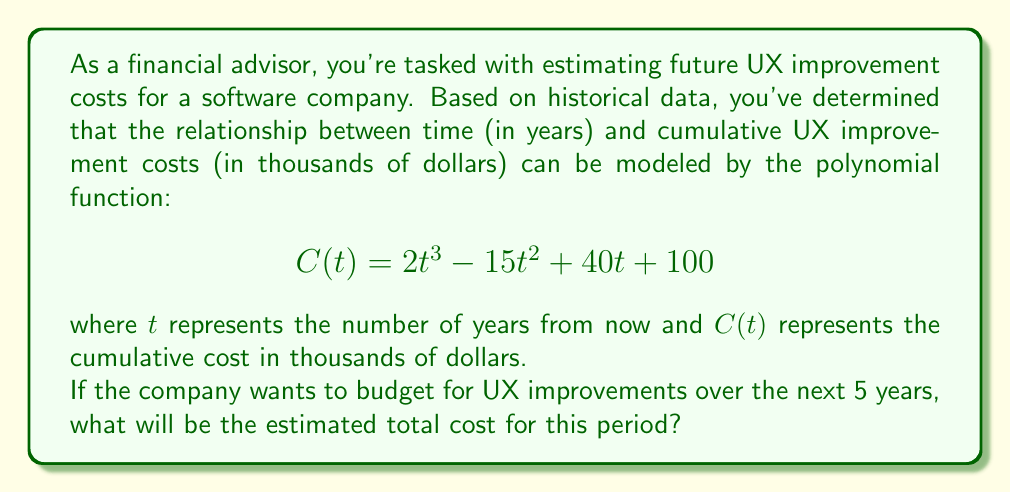Provide a solution to this math problem. To solve this problem, we need to follow these steps:

1) The function $C(t)$ gives us the cumulative cost up to year $t$. To find the total cost over the 5-year period, we need to calculate $C(5) - C(0)$.

2) Let's calculate $C(5)$:
   $$C(5) = 2(5^3) - 15(5^2) + 40(5) + 100$$
   $$= 2(125) - 15(25) + 200 + 100$$
   $$= 250 - 375 + 200 + 100$$
   $$= 175$$ thousand dollars

3) Now, let's calculate $C(0)$:
   $$C(0) = 2(0^3) - 15(0^2) + 40(0) + 100$$
   $$= 0 - 0 + 0 + 100$$
   $$= 100$$ thousand dollars

4) The total cost over the 5-year period is the difference:
   $$C(5) - C(0) = 175 - 100 = 75$$ thousand dollars

Therefore, the estimated total cost for UX improvements over the next 5 years is $75,000.
Answer: $75,000 